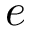Convert formula to latex. <formula><loc_0><loc_0><loc_500><loc_500>e</formula> 